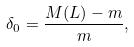Convert formula to latex. <formula><loc_0><loc_0><loc_500><loc_500>\delta _ { 0 } = \frac { M ( L ) - m } { m } ,</formula> 